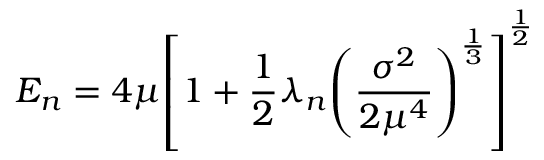<formula> <loc_0><loc_0><loc_500><loc_500>E _ { n } = 4 \mu { \left [ 1 + \frac { 1 } { 2 } \lambda _ { n } { \left ( \frac { \sigma ^ { 2 } } { 2 \mu ^ { 4 } } \right ) } ^ { \frac { 1 } { 3 } } \right ] } ^ { \frac { 1 } { 2 } }</formula> 